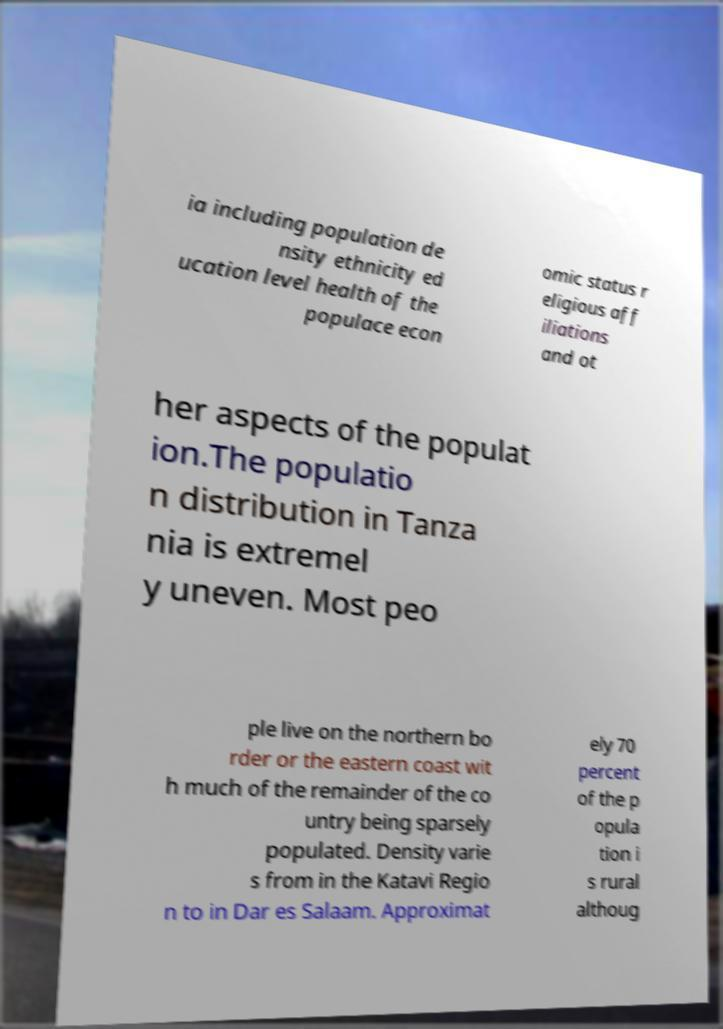Can you read and provide the text displayed in the image?This photo seems to have some interesting text. Can you extract and type it out for me? ia including population de nsity ethnicity ed ucation level health of the populace econ omic status r eligious aff iliations and ot her aspects of the populat ion.The populatio n distribution in Tanza nia is extremel y uneven. Most peo ple live on the northern bo rder or the eastern coast wit h much of the remainder of the co untry being sparsely populated. Density varie s from in the Katavi Regio n to in Dar es Salaam. Approximat ely 70 percent of the p opula tion i s rural althoug 